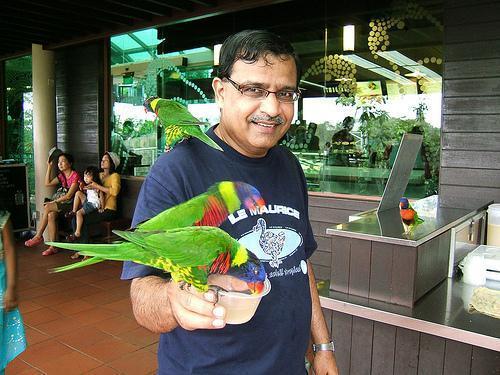How many birds are there?
Give a very brief answer. 3. 